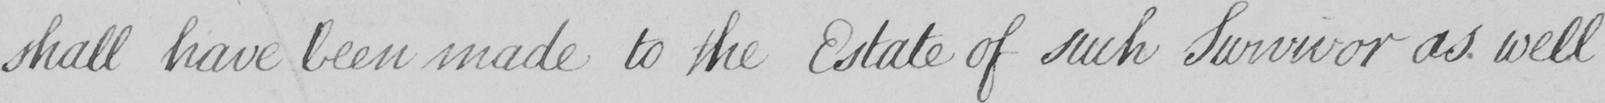Please provide the text content of this handwritten line. shall have been made to the Estate of such Survivor as well 